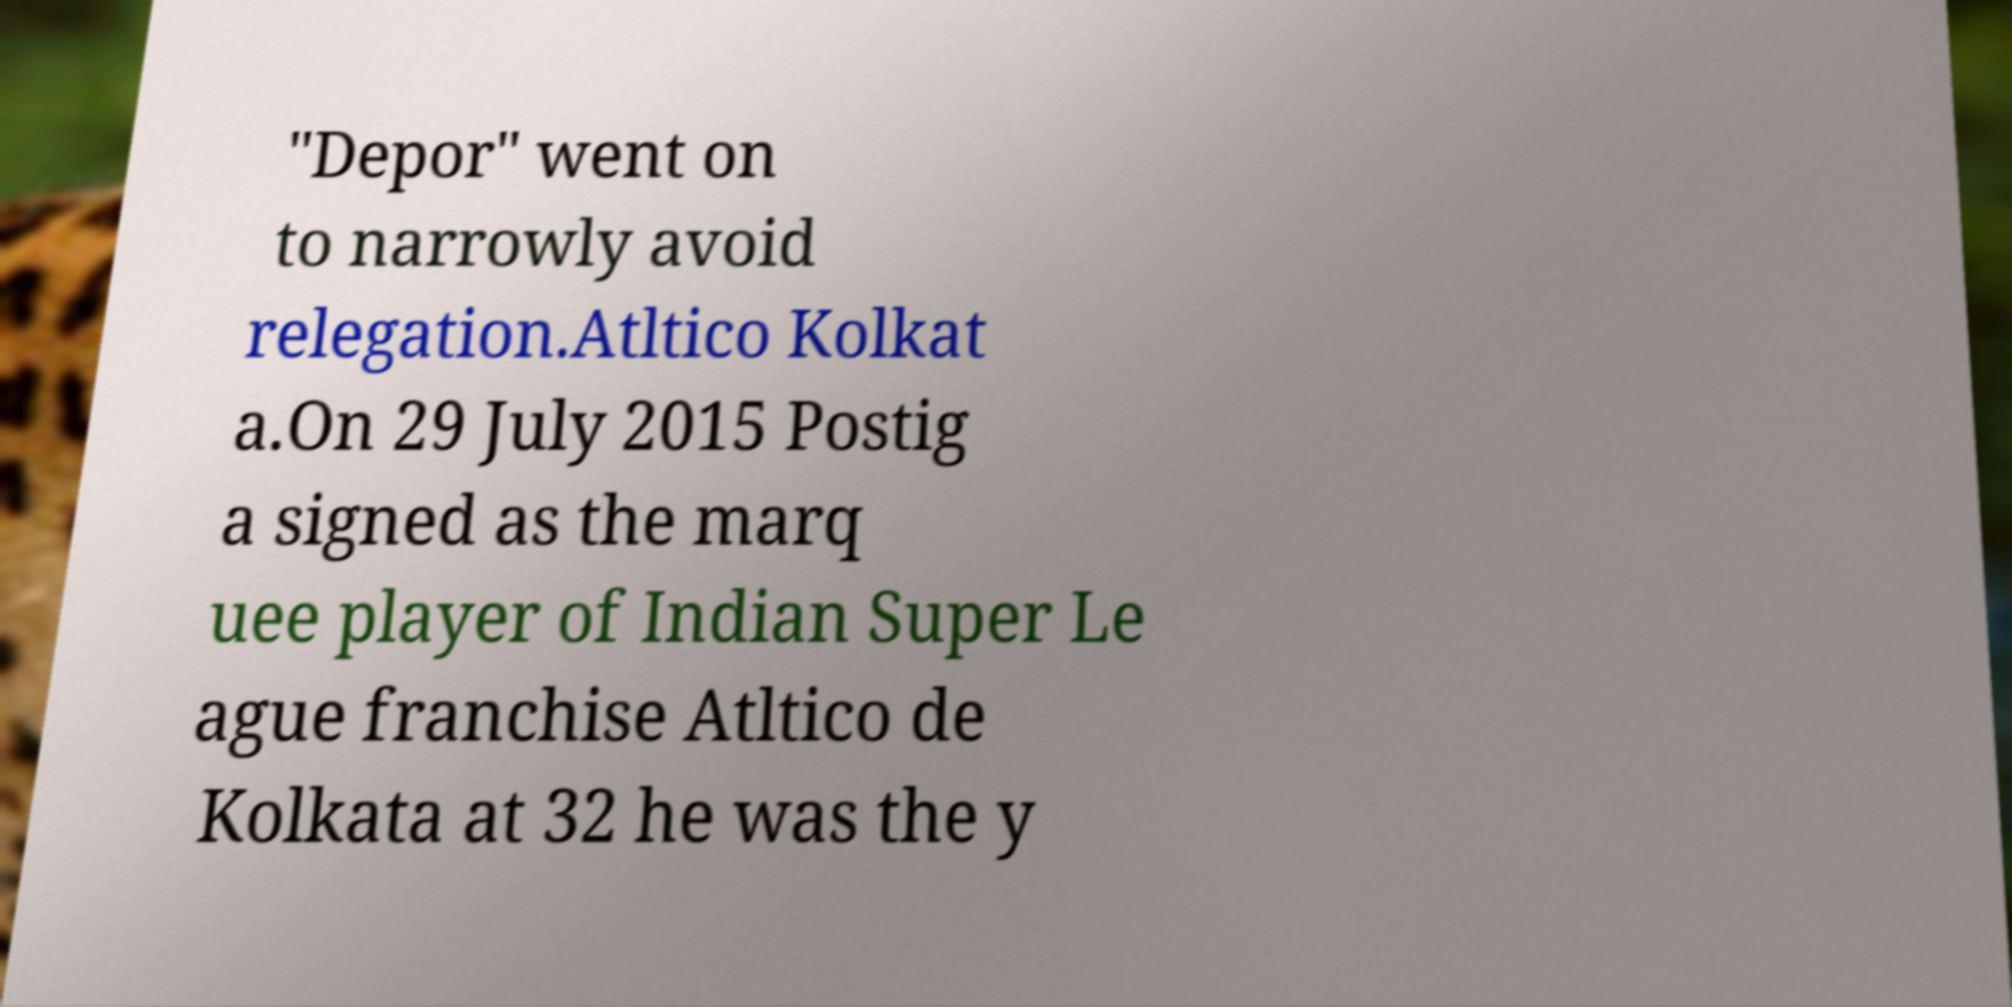I need the written content from this picture converted into text. Can you do that? "Depor" went on to narrowly avoid relegation.Atltico Kolkat a.On 29 July 2015 Postig a signed as the marq uee player of Indian Super Le ague franchise Atltico de Kolkata at 32 he was the y 